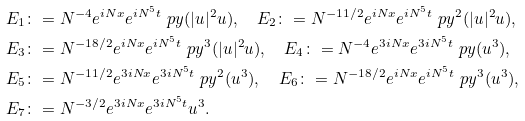Convert formula to latex. <formula><loc_0><loc_0><loc_500><loc_500>& E _ { 1 } \colon = N ^ { - 4 } e ^ { i N x } e ^ { i N ^ { 5 } t } \ p y ( | u | ^ { 2 } u ) , \quad E _ { 2 } \colon = N ^ { - 1 1 / 2 } e ^ { i N x } e ^ { i N ^ { 5 } t } \ p y ^ { 2 } ( | u | ^ { 2 } u ) , \\ & E _ { 3 } \colon = N ^ { - 1 8 / 2 } e ^ { i N x } e ^ { i N ^ { 5 } t } \ p y ^ { 3 } ( | u | ^ { 2 } u ) , \quad E _ { 4 } \colon = N ^ { - 4 } e ^ { 3 i N x } e ^ { 3 i N ^ { 5 } t } \ p y ( u ^ { 3 } ) , \\ & E _ { 5 } \colon = N ^ { - 1 1 / 2 } e ^ { 3 i N x } e ^ { 3 i N ^ { 5 } t } \ p y ^ { 2 } ( u ^ { 3 } ) , \quad E _ { 6 } \colon = N ^ { - 1 8 / 2 } e ^ { i N x } e ^ { i N ^ { 5 } t } \ p y ^ { 3 } ( u ^ { 3 } ) , \\ & E _ { 7 } \colon = N ^ { - 3 / 2 } e ^ { 3 i N x } e ^ { 3 i N ^ { 5 } t } u ^ { 3 } .</formula> 